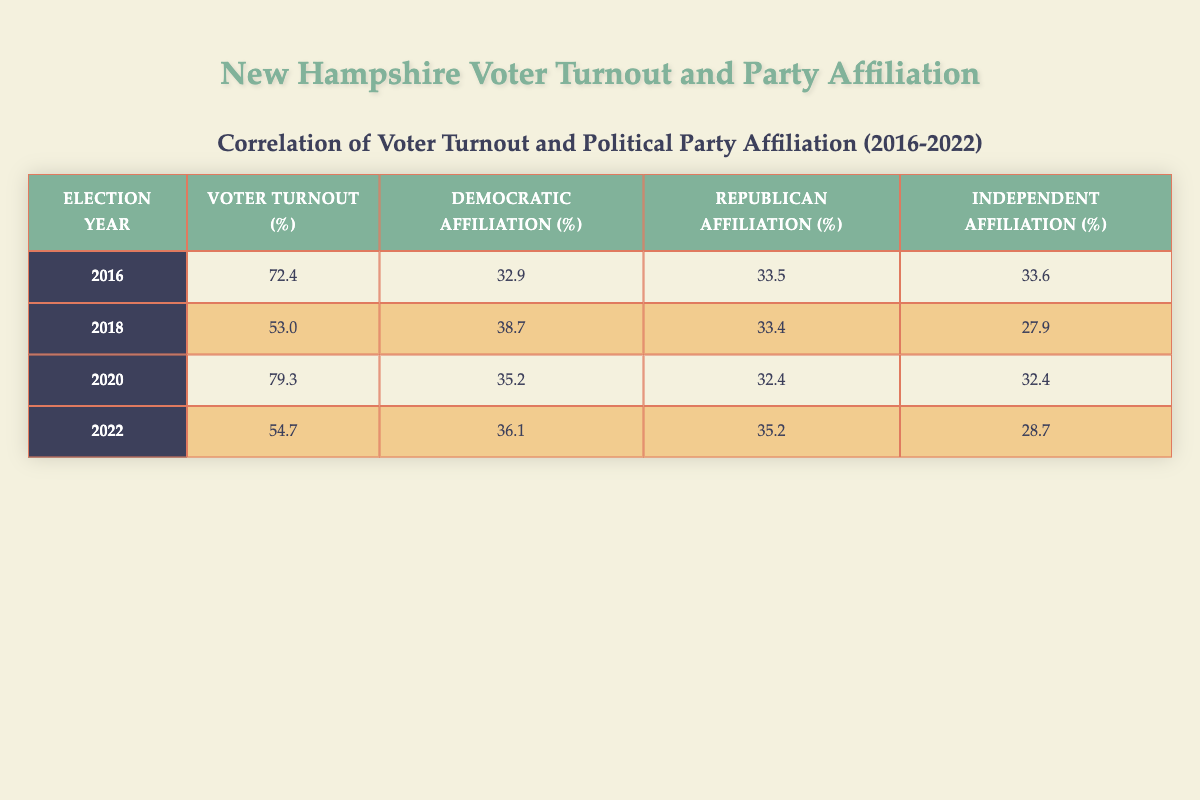What was the voter turnout percentage in the 2020 election? By looking at the table, we can directly find the row for the year 2020, where it states that the voter turnout percentage was 79.3.
Answer: 79.3 Which election year had the highest percentage of Democratic affiliation? In the table, we see the Democratic affiliation percentages: 32.9 in 2016, 38.7 in 2018, 35.2 in 2020, and 36.1 in 2022. The highest value is 38.7 in 2018.
Answer: 2018 What was the average voter turnout percentage across the years listed? The voter turnout percentages for the years are 72.4, 53.0, 79.3, and 54.7. First, we sum these values: (72.4 + 53.0 + 79.3 + 54.7) = 259.4. Then, we divide by the number of elections (4), resulting in an average of 259.4/4 = 64.85.
Answer: 64.85 In which election year did the Independent affiliation percentage drop below 30%? By reviewing the independent affiliation percentages (33.6, 27.9, 32.4, 28.7 for the respective years), we identify that the percentage only drops below 30% in 2018 (27.9) and 2022 (28.7). Both years indicate a drop, but 27.9 is below 30%.
Answer: 2018 Is it true that the Republican affiliation percentage increased from 2020 to 2022? Checking the Republican affiliation percentages, we find 32.4 in 2020 and 35.2 in 2022. Since 35.2 is greater than 32.4, it is true that it increased.
Answer: Yes What was the difference in voter turnout percentage between 2016 and 2022? The voter turnout percentages are 72.4 for 2016 and 54.7 for 2022. To find the difference, we subtract: 72.4 - 54.7 = 17.7.
Answer: 17.7 In which year did the voter turnout percentage decrease compared to the previous election year? Analyzing the voter turnout percentages: 72.4 in 2016 and 53.0 in 2018 shows a decrease, as does going from 79.3 in 2020 to 54.7 in 2022. Therefore, the years 2018 and 2022 had decreases compared to their previous years.
Answer: 2018 and 2022 What is the trend of Democratic affiliation from 2016 to 2022? Observing the Democratic affiliation percentages: 32.9 in 2016, 38.7 in 2018, 35.2 in 2020, and 36.1 in 2022. Starting at 32.9, it rises to 38.7 and then decreases to 35.2, before rising again to 36.1. This suggests fluctuations without a clear upward or downward trend.
Answer: Fluctuations What was the overall percentage of Independent voters in the 2016 election compared to the overall percentage of Democratic and Republican voters combined? The Independent percentage for 2016 is 33.6, while the combined percentage for Democratic and Republican is 32.9 + 33.5 = 66.4. Thus, Independent voters made up a smaller portion (33.6) compared to the combined Democratic and Republican (66.4).
Answer: No 